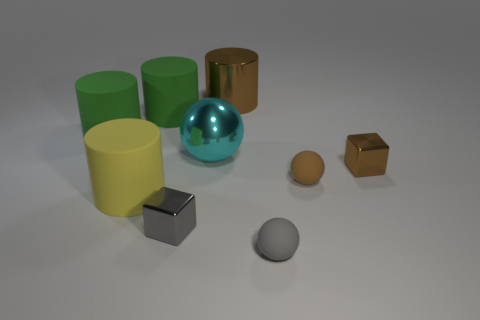The gray thing that is the same material as the cyan sphere is what shape?
Your answer should be compact. Cube. What is the size of the shiny object that is the same color as the metallic cylinder?
Offer a very short reply. Small. Are there the same number of brown objects that are to the left of the gray matte object and large brown cylinders that are in front of the tiny brown metal cube?
Ensure brevity in your answer.  No. How many small gray shiny objects are the same shape as the tiny brown rubber thing?
Your answer should be very brief. 0. Are there any yellow cubes that have the same material as the small brown sphere?
Ensure brevity in your answer.  No. There is a metallic thing that is the same color as the metallic cylinder; what shape is it?
Provide a short and direct response. Cube. How many cylinders are there?
Keep it short and to the point. 4. What number of balls are either large cyan metallic objects or tiny things?
Ensure brevity in your answer.  3. The metal object that is the same size as the gray cube is what color?
Your answer should be very brief. Brown. What number of shiny objects are both to the right of the small gray block and in front of the cyan shiny object?
Offer a very short reply. 1. 